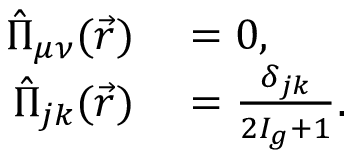<formula> <loc_0><loc_0><loc_500><loc_500>\begin{array} { r l } { \hat { \Pi } _ { \mu \nu } ( \vec { r } ) } & = 0 , } \\ { \hat { \Pi } _ { j k } ( \vec { r } ) } & = \frac { \delta _ { j k } } { 2 I _ { g } + 1 } . } \end{array}</formula> 